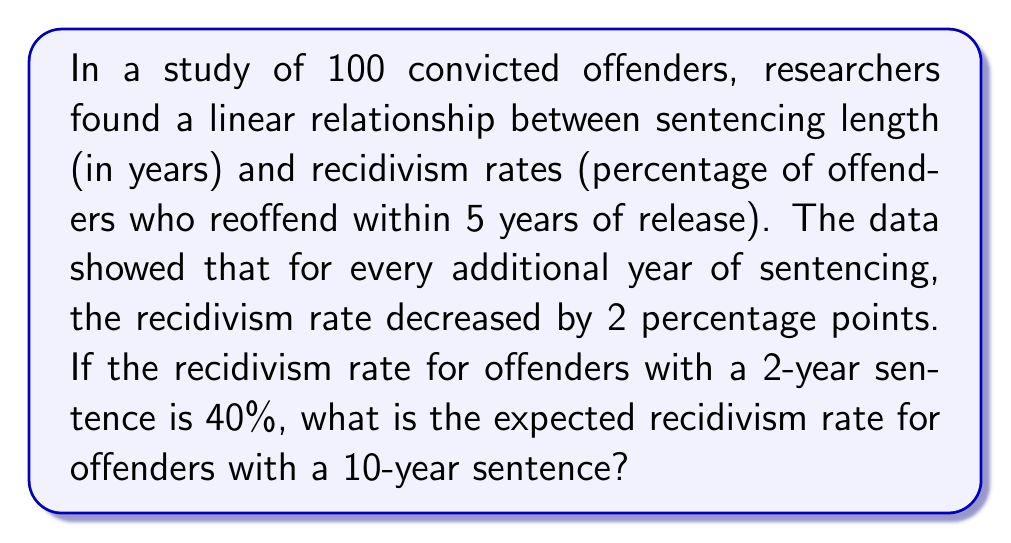What is the answer to this math problem? Let's approach this step-by-step:

1) First, we need to identify the variables:
   Let $x$ = sentencing length in years
   Let $y$ = recidivism rate in percentage

2) We're given that this is a linear relationship, so we can use the slope-intercept form of a line:
   $y = mx + b$
   where $m$ is the slope and $b$ is the y-intercept

3) We're told that for every additional year of sentencing, the recidivism rate decreases by 2 percentage points. This gives us the slope:
   $m = -2$ (negative because the rate decreases)

4) We're also given a point on this line: when the sentence is 2 years (x = 2), the recidivism rate is 40% (y = 40)
   $(2, 40)$

5) We can use this point to find $b$ in our equation:
   $40 = -2(2) + b$
   $40 = -4 + b$
   $b = 44$

6) Now we have our complete linear equation:
   $y = -2x + 44$

7) To find the recidivism rate for a 10-year sentence, we simply plug in $x = 10$:
   $y = -2(10) + 44$
   $y = -20 + 44$
   $y = 24$

Therefore, the expected recidivism rate for offenders with a 10-year sentence is 24%.
Answer: 24% 